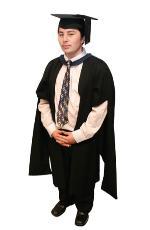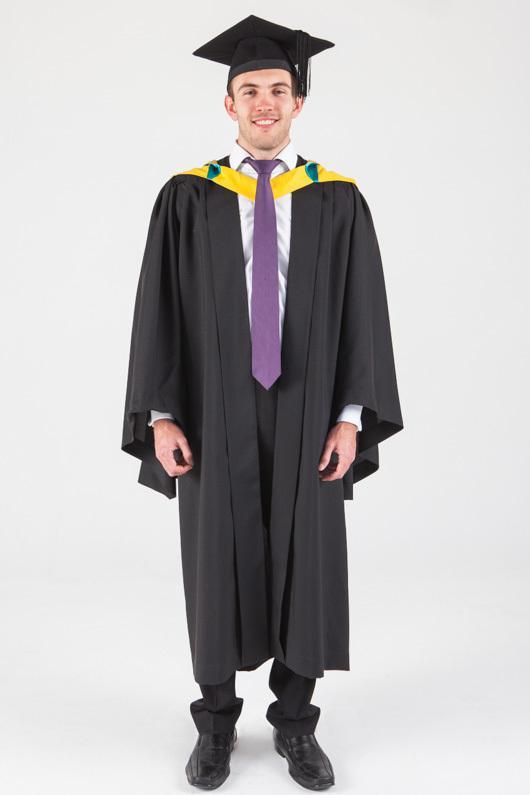The first image is the image on the left, the second image is the image on the right. Examine the images to the left and right. Is the description "An image shows a male graduate wearing something yellow around his neck." accurate? Answer yes or no. Yes. The first image is the image on the left, the second image is the image on the right. For the images displayed, is the sentence "In both images a man wearing a black cap and gown and purple tie is standing facing forward with his arms at his sides." factually correct? Answer yes or no. No. 